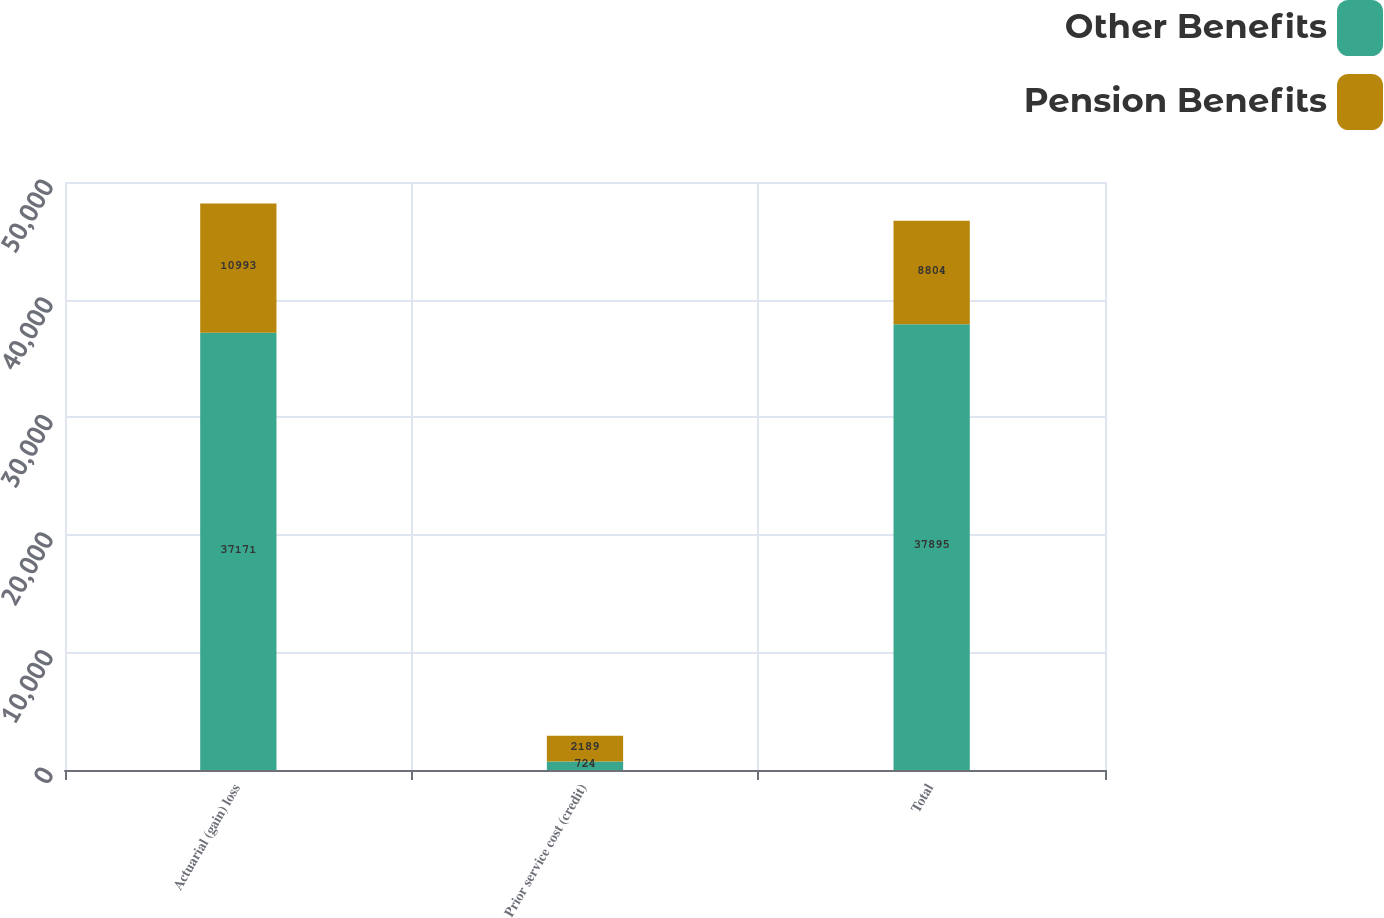Convert chart. <chart><loc_0><loc_0><loc_500><loc_500><stacked_bar_chart><ecel><fcel>Actuarial (gain) loss<fcel>Prior service cost (credit)<fcel>Total<nl><fcel>Other Benefits<fcel>37171<fcel>724<fcel>37895<nl><fcel>Pension Benefits<fcel>10993<fcel>2189<fcel>8804<nl></chart> 